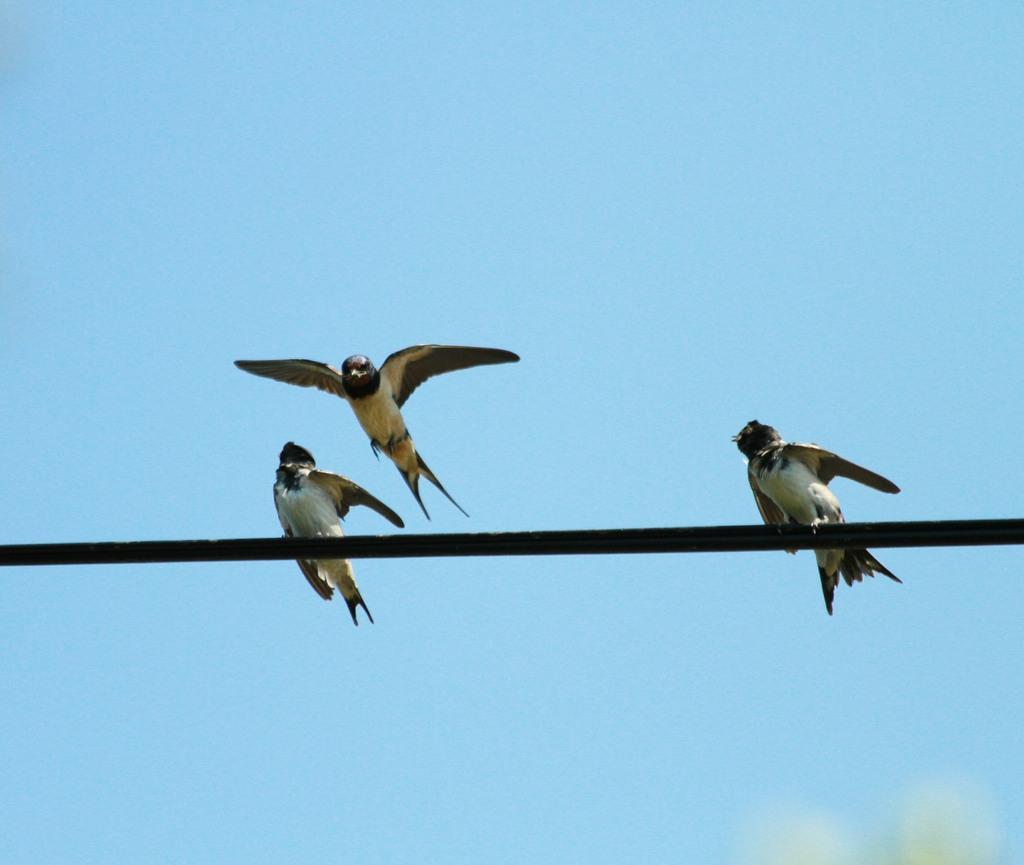Describe this image in one or two sentences. In this picture we can see two birds on a stick and one bird is flying and we can see sky in the background. 